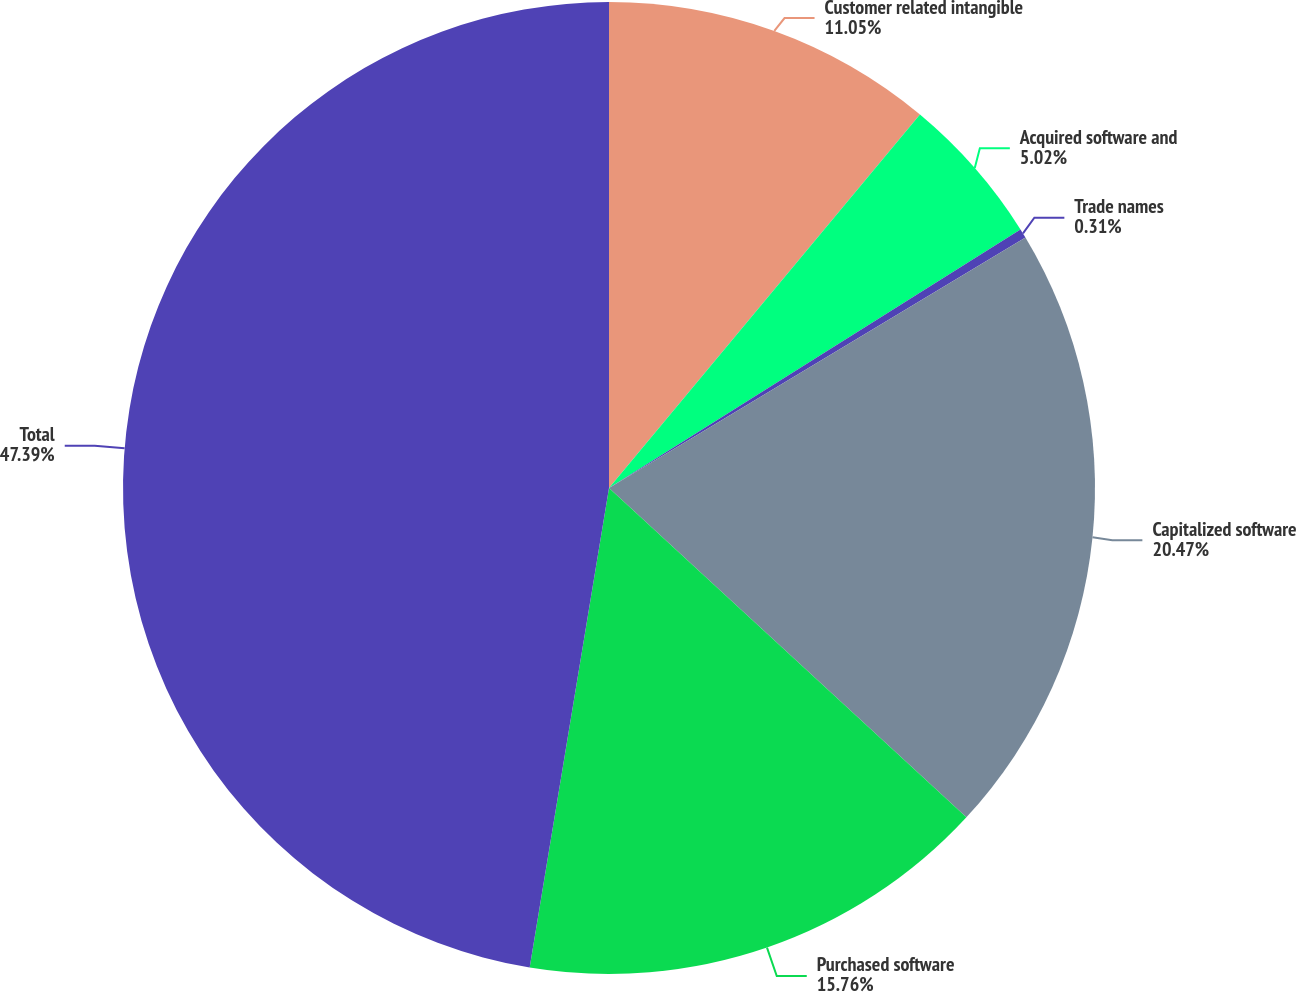Convert chart to OTSL. <chart><loc_0><loc_0><loc_500><loc_500><pie_chart><fcel>Customer related intangible<fcel>Acquired software and<fcel>Trade names<fcel>Capitalized software<fcel>Purchased software<fcel>Total<nl><fcel>11.05%<fcel>5.02%<fcel>0.31%<fcel>20.47%<fcel>15.76%<fcel>47.39%<nl></chart> 